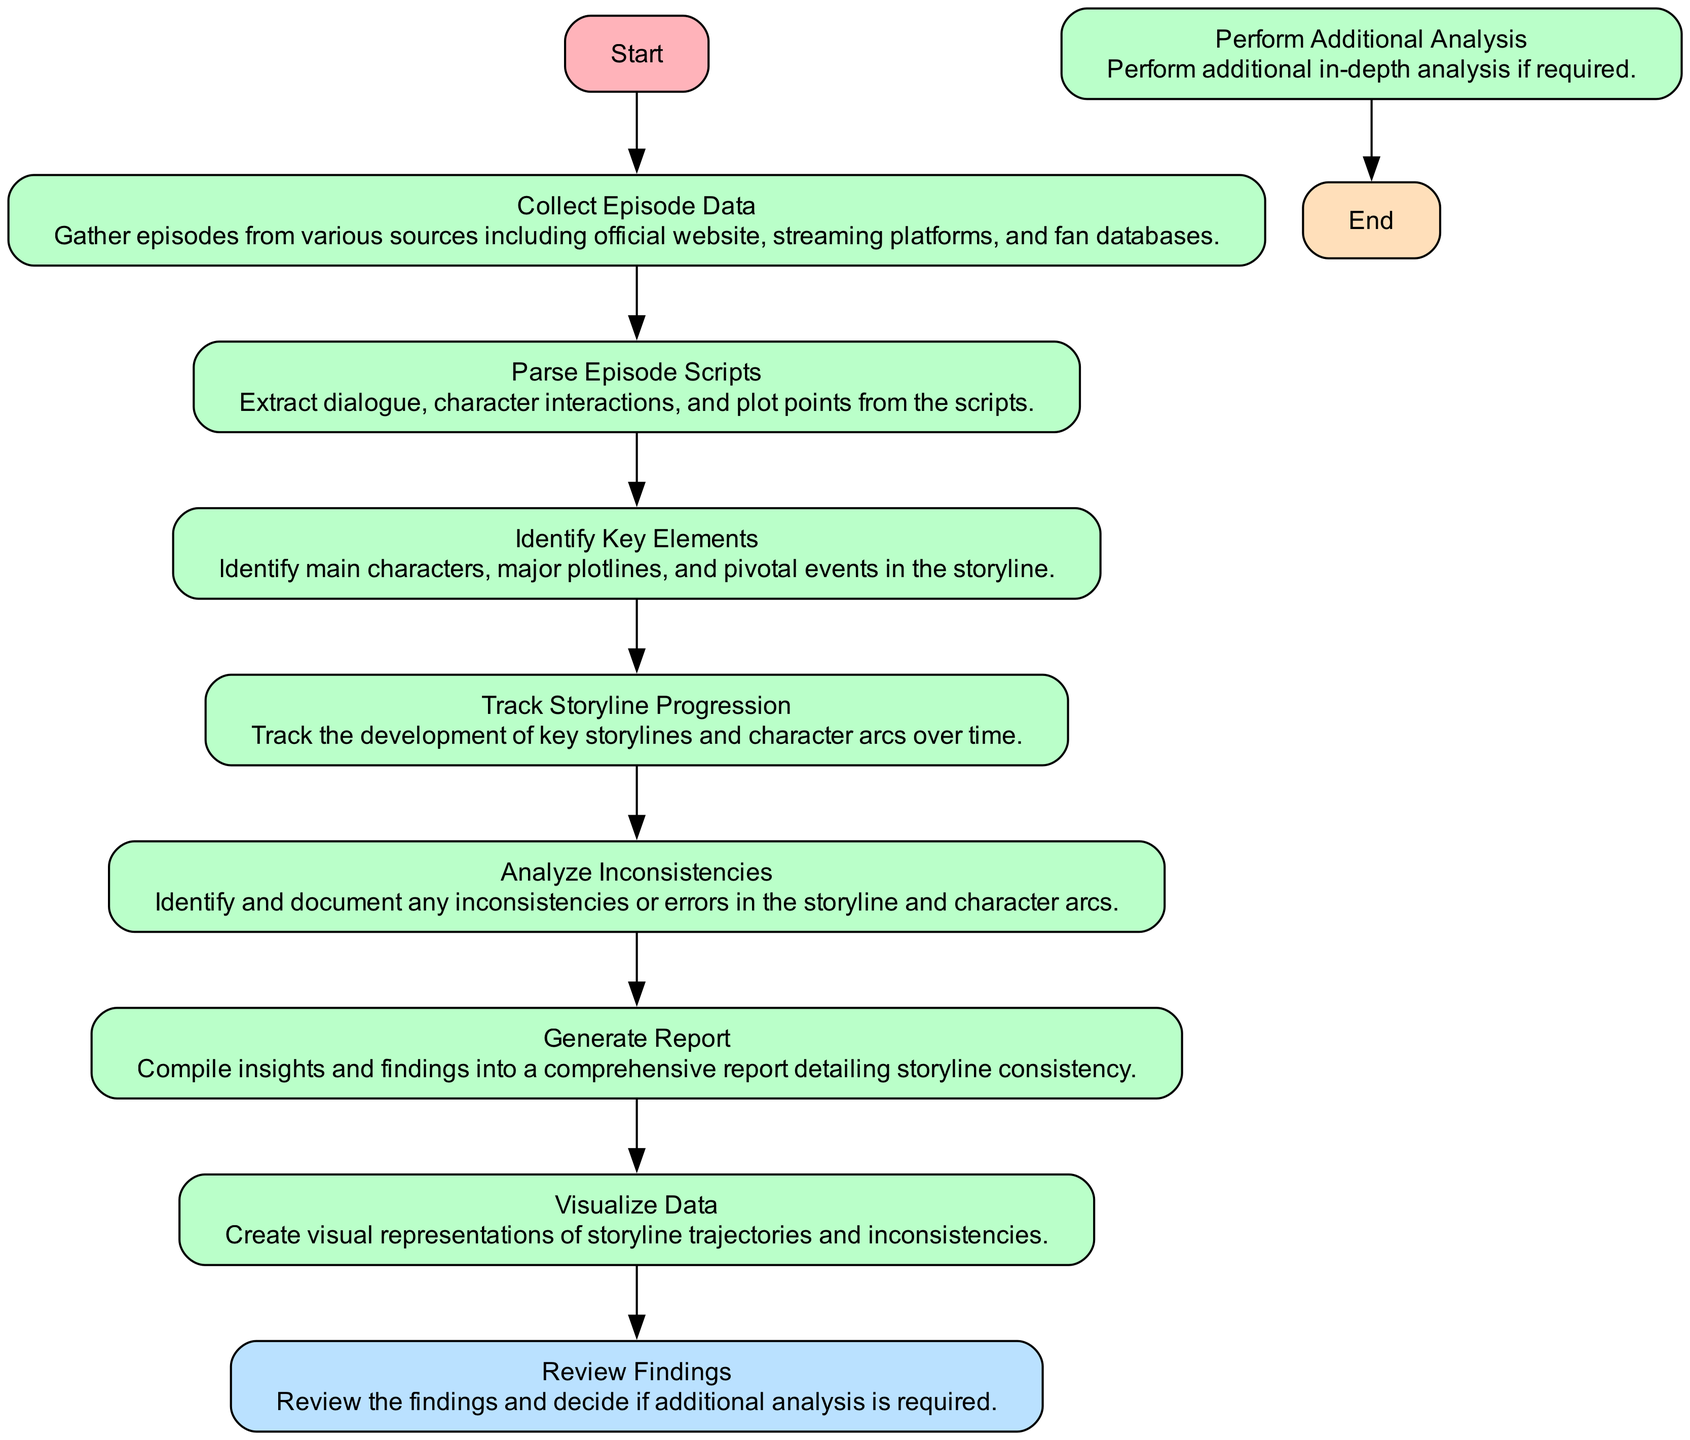What is the first node in the diagram? The first node is labeled "Start," which indicates the beginning of the process outlined in the flow chart.
Answer: Start How many process nodes are in the diagram? There are six process nodes: "Collect Episode Data," "Parse Episode Scripts," "Identify Key Elements," "Track Storyline Progression," "Analyze Inconsistencies," and "Generate Report."
Answer: Six What do the nodes after "Track Storyline Progression" signify? After "Track Storyline Progression," the next node is "Analyze Inconsistencies," which signifies that once storylines are tracked, the inconsistencies are analyzed.
Answer: Analyze Inconsistencies What condition leads to "Perform Additional Analysis"? The condition that leads to "Perform Additional Analysis" is if the findings from "Review Findings" require additional analysis, indicated by a 'yes' path.
Answer: Yes How many edges connect to the "Review Findings" node, and what does this signify? There are two edges connecting to "Review Findings," which signifies a decision point leading either to "Perform Additional Analysis" or to the end of the process.
Answer: Two Which node directly follows "Identify Key Elements"? The node that directly follows "Identify Key Elements" is "Track Storyline Progression," showing the sequential flow from identifying elements to tracking them in the storyline.
Answer: Track Storyline Progression What is the final node in the flow chart? The final node in the flow chart is labeled "End," indicating the conclusion of the analysis process.
Answer: End What type of node is "Analyze Inconsistencies"? "Analyze Inconsistencies" is a process type node, which indicates a step in the analysis that requires action or processing of information.
Answer: Process What happens if the findings do not require additional analysis? If the findings do not require additional analysis, the flow proceeds directly to the "End" node, indicating termination of the analysis process.
Answer: End 